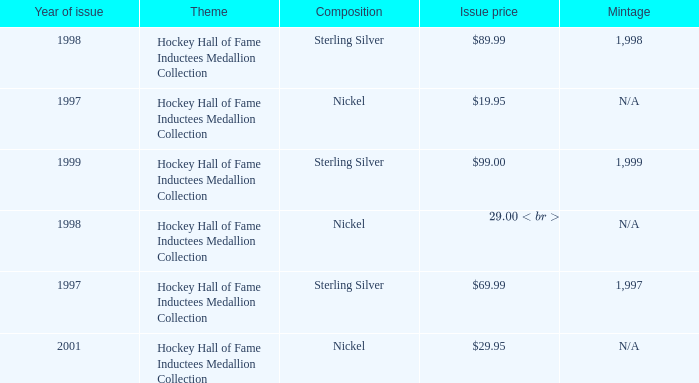How many years was the issue price $19.95? 1.0. 